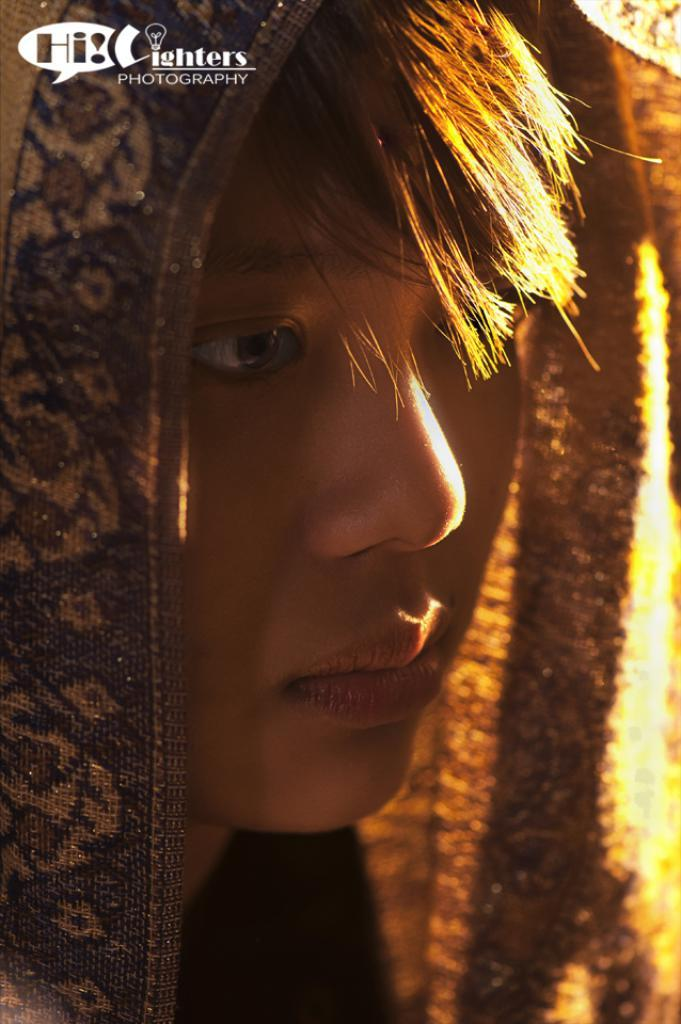Who or what is the main subject in the image? There is a person in the image. What is the person wearing on their head? The person has a cloth on their head. Where is the text located in the image? The text is in the top left corner of the image. What type of symbol or design is present in the image? There is a logo in the image. How far away is the cart from the person in the image? There is no cart present in the image, so it is not possible to determine the distance between the person and a cart. 